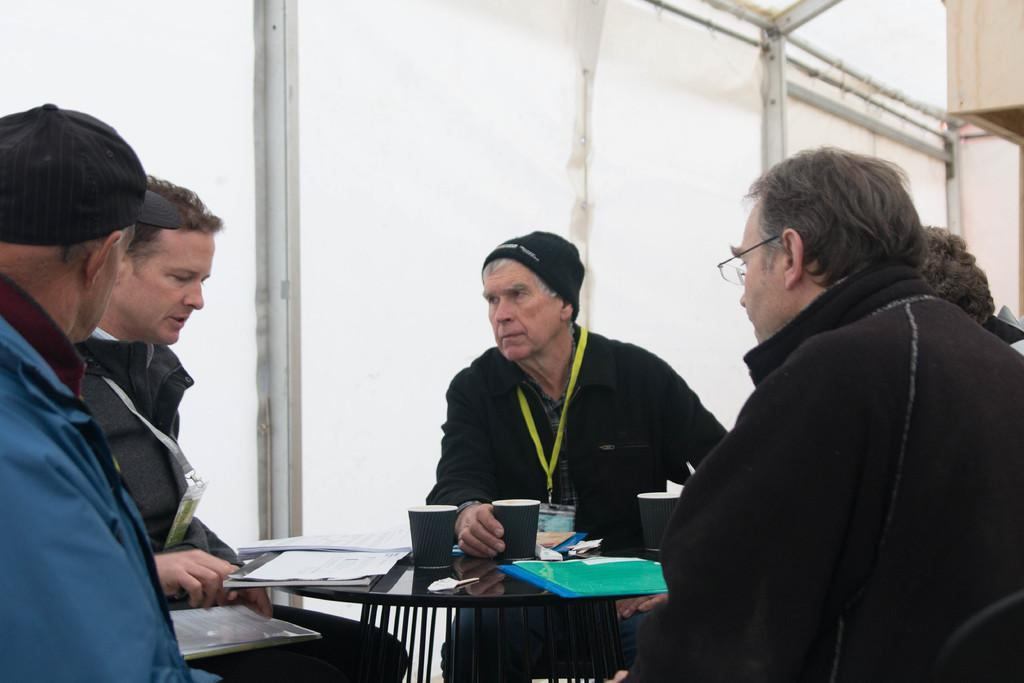How many people are sitting in the image? There are five people sitting on chairs in the image. What objects are on the table in the image? There is a cup, a file, and papers on the table in the image. What type of yam is being served on the table in the image? There is no yam present in the image; the objects on the table are a cup, a file, and papers. 